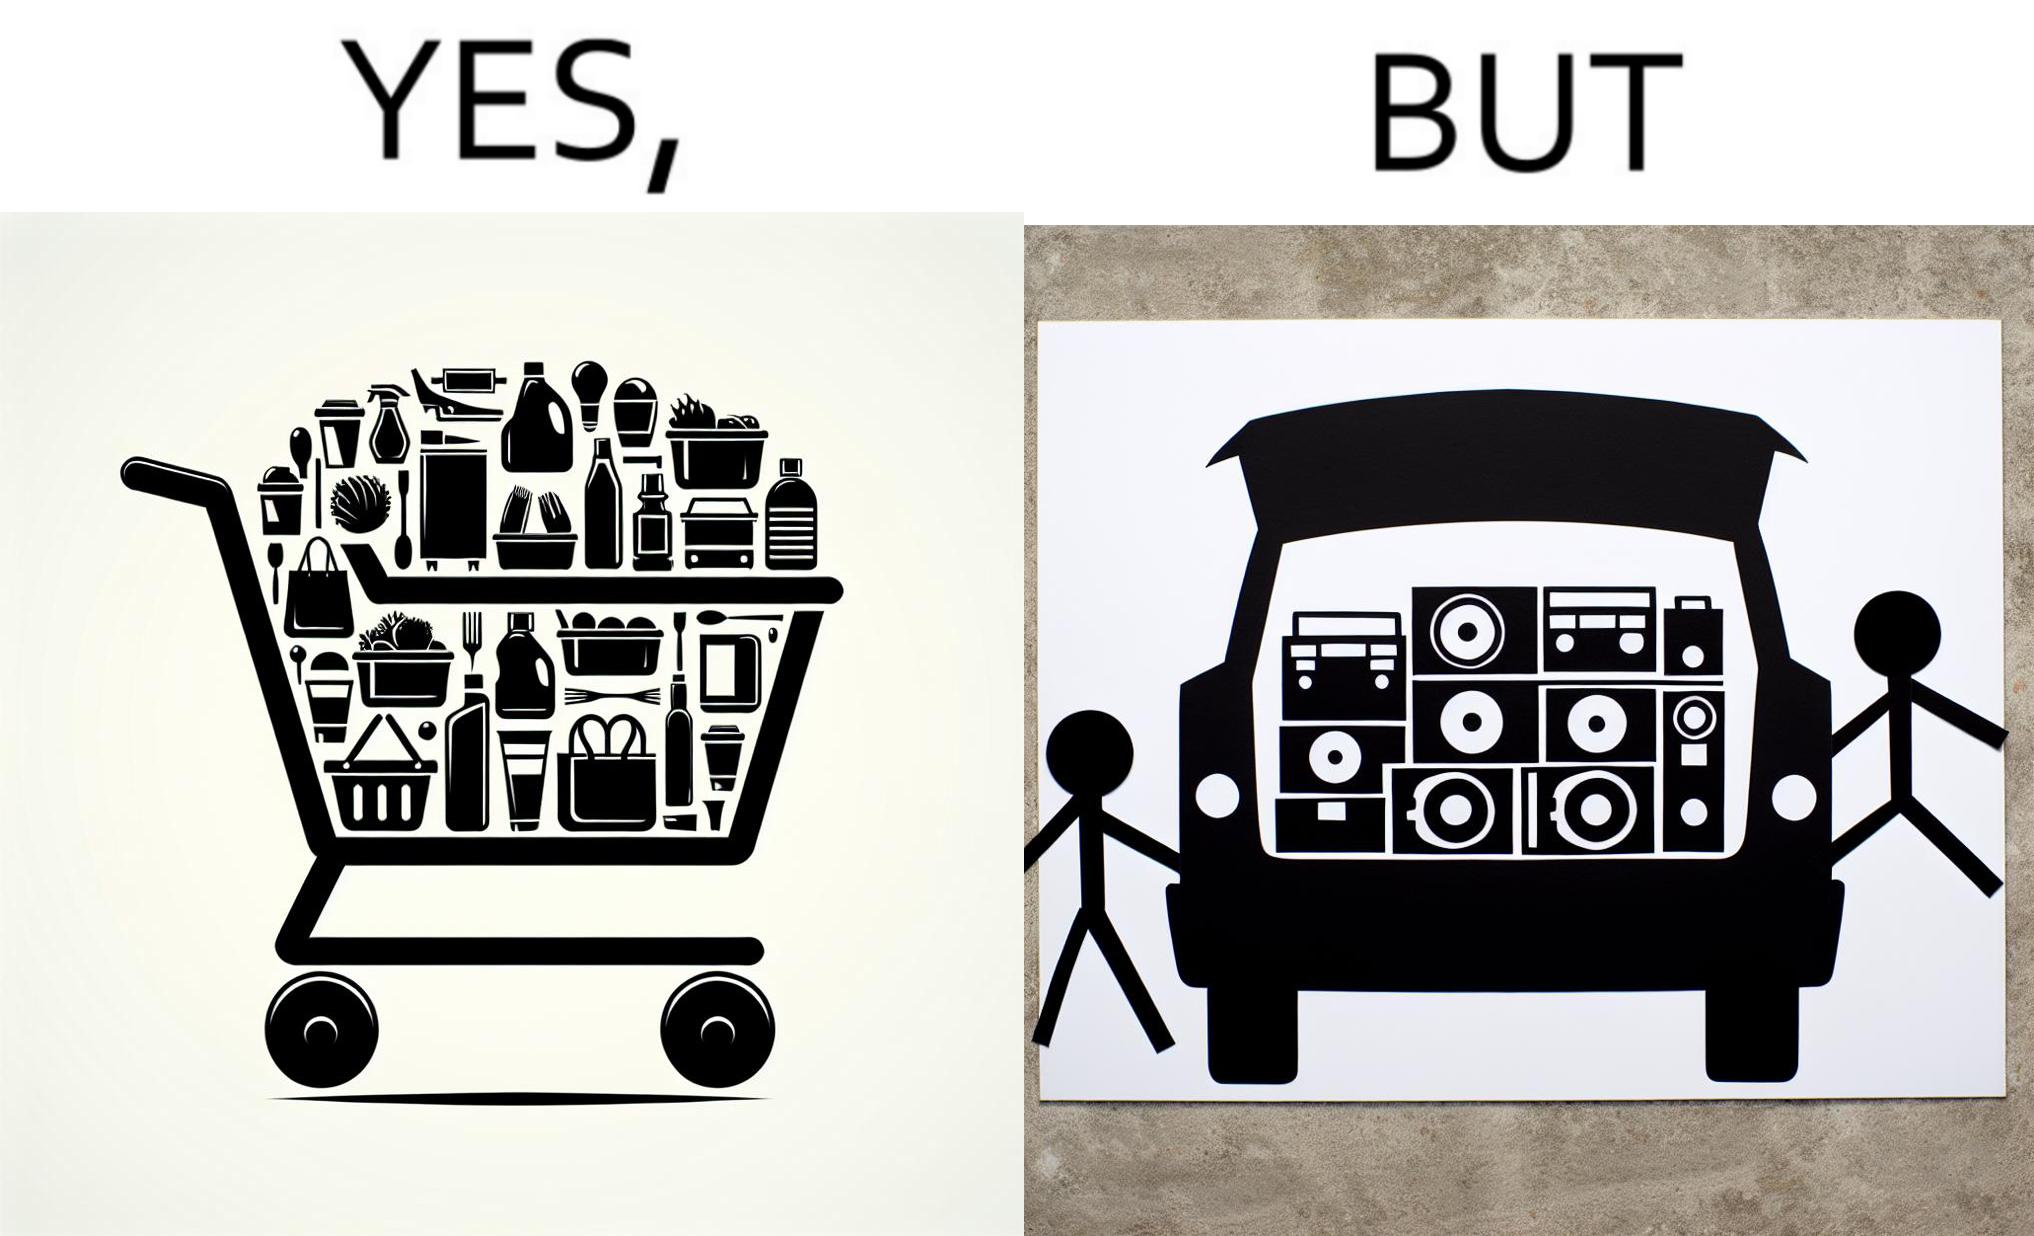Describe the satirical element in this image. The image is ironic, because a car trunk was earlier designed to keep some extra luggage or things but people nowadays get speakers installed in the trunk which in turn reduces the space in the trunk and making it difficult for people to store the extra luggage in the trunk 